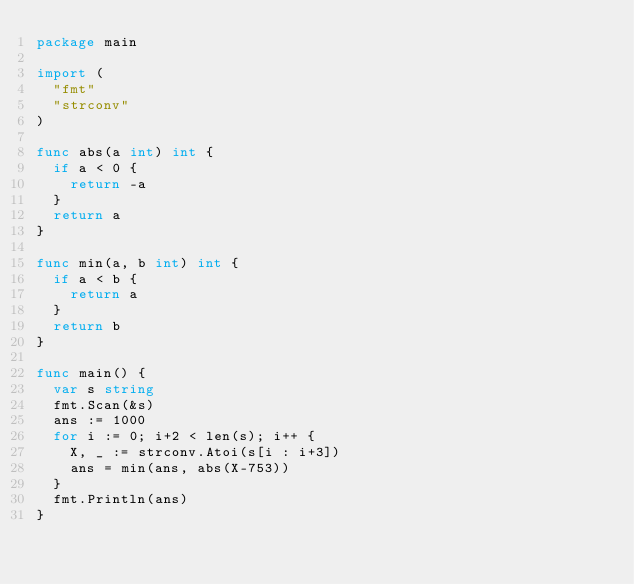<code> <loc_0><loc_0><loc_500><loc_500><_Go_>package main

import (
	"fmt"
	"strconv"
)

func abs(a int) int {
	if a < 0 {
		return -a
	}
	return a
}

func min(a, b int) int {
	if a < b {
		return a
	}
	return b
}

func main() {
	var s string
	fmt.Scan(&s)
	ans := 1000
	for i := 0; i+2 < len(s); i++ {
		X, _ := strconv.Atoi(s[i : i+3])
		ans = min(ans, abs(X-753))
	}
	fmt.Println(ans)
}
</code> 